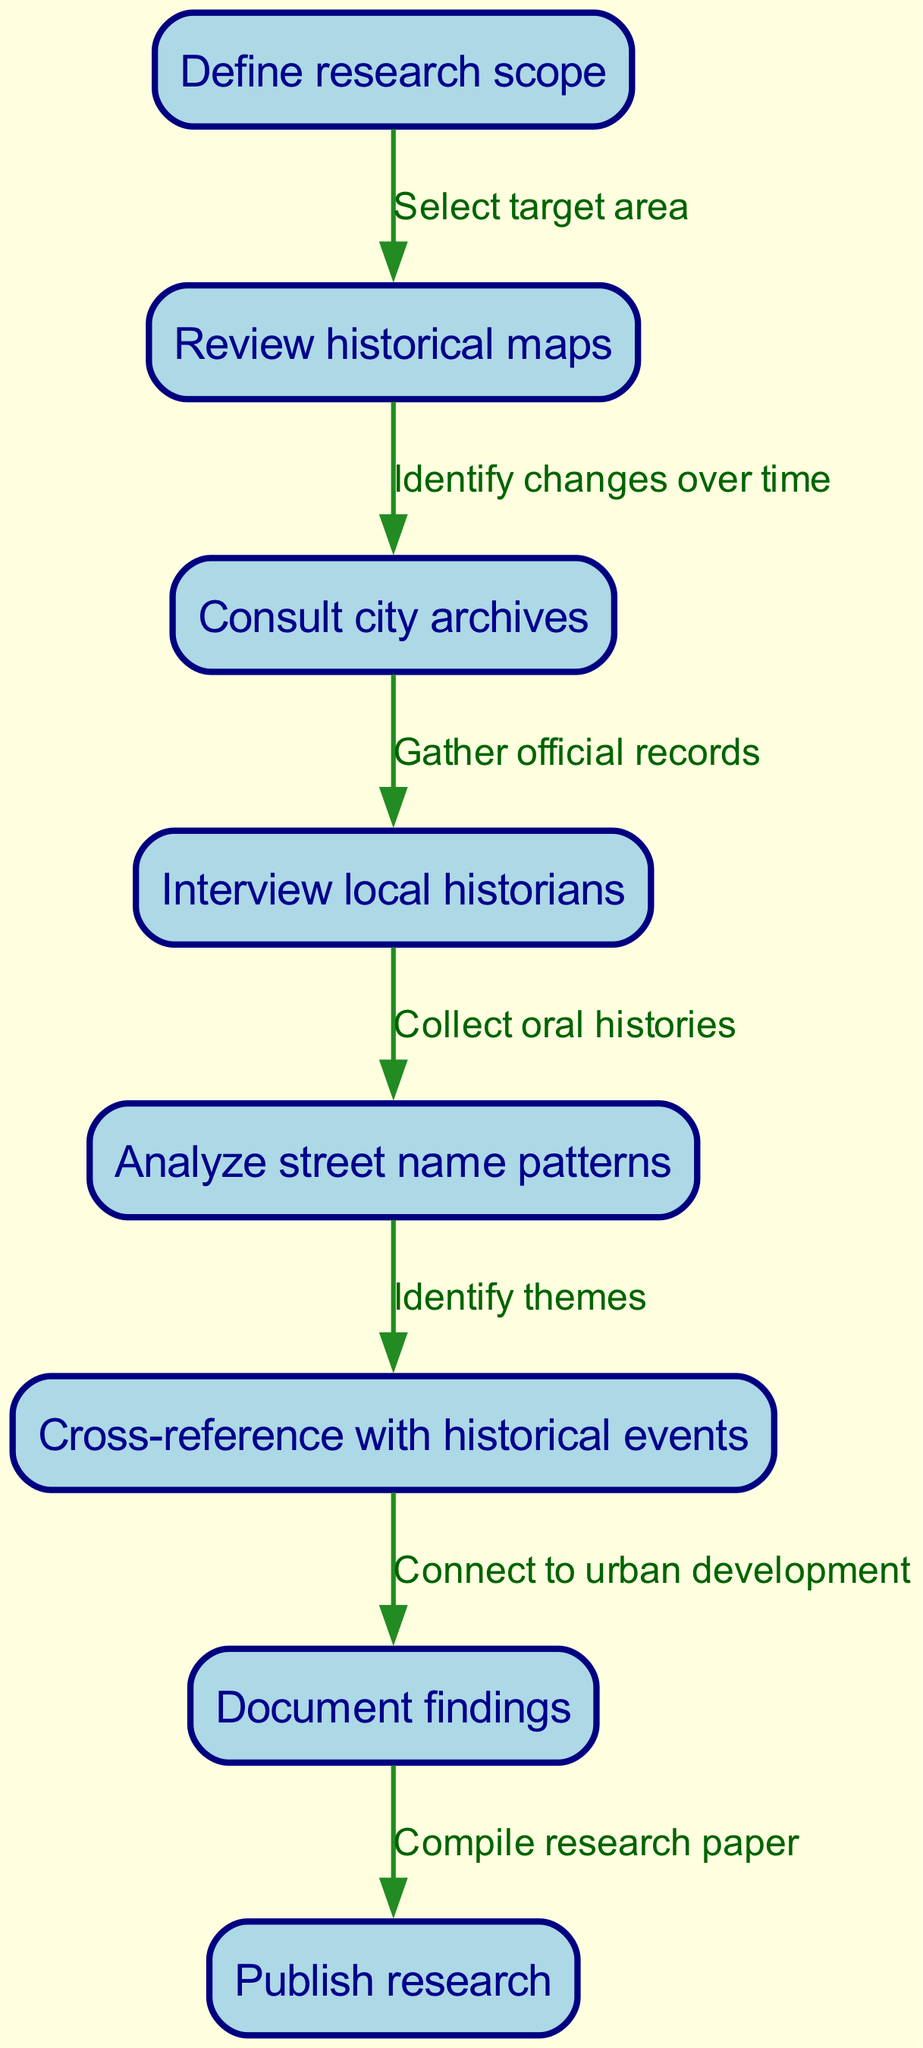What is the first step in the process? The diagram indicates that the first step is to "Define research scope." This is the starting node in the flow chart, leading to following actions.
Answer: Define research scope How many total nodes are there in the diagram? By counting the nodes listed in the diagram, there are eight distinct nodes outlined.
Answer: Eight What action follows "Review historical maps"? Based on the flow of the diagram, "Consult city archives" is the action that follows "Review historical maps." This connection shows the progression in the research process.
Answer: Consult city archives Which node connects "Interview local historians" to "Analyze street name patterns"? The edge labeled "Collect oral histories" connects "Interview local historians" to "Analyze street name patterns," indicating that collecting oral histories is vital in understanding street names.
Answer: Collect oral histories How does "Analyze street name patterns" relate to "Document findings"? The relationship is established by the edge "Identify themes." After analyzing street name patterns, this step identifies themes that are crucial for documenting findings effectively.
Answer: Identify themes What is the last action documented before publication? The final action before publication is to "Document findings." This is essential for compiling a comprehensive overview that can be published later.
Answer: Document findings Which step involves gathering data from local historians? The step titled "Interview local historians" specifically involves gathering data and insights from those who have researched local history, contributing significantly to the overall findings.
Answer: Interview local historians How many edges are present in the diagram, showing connections between steps? There are seven edges present in the diagram, representing the various connections that guide the flow of information from one step to another in the research process.
Answer: Seven After documenting findings, what is the next step? The subsequent step after documenting findings is to "Publish research," indicating that successful documentation leads to sharing the research publicly.
Answer: Publish research 